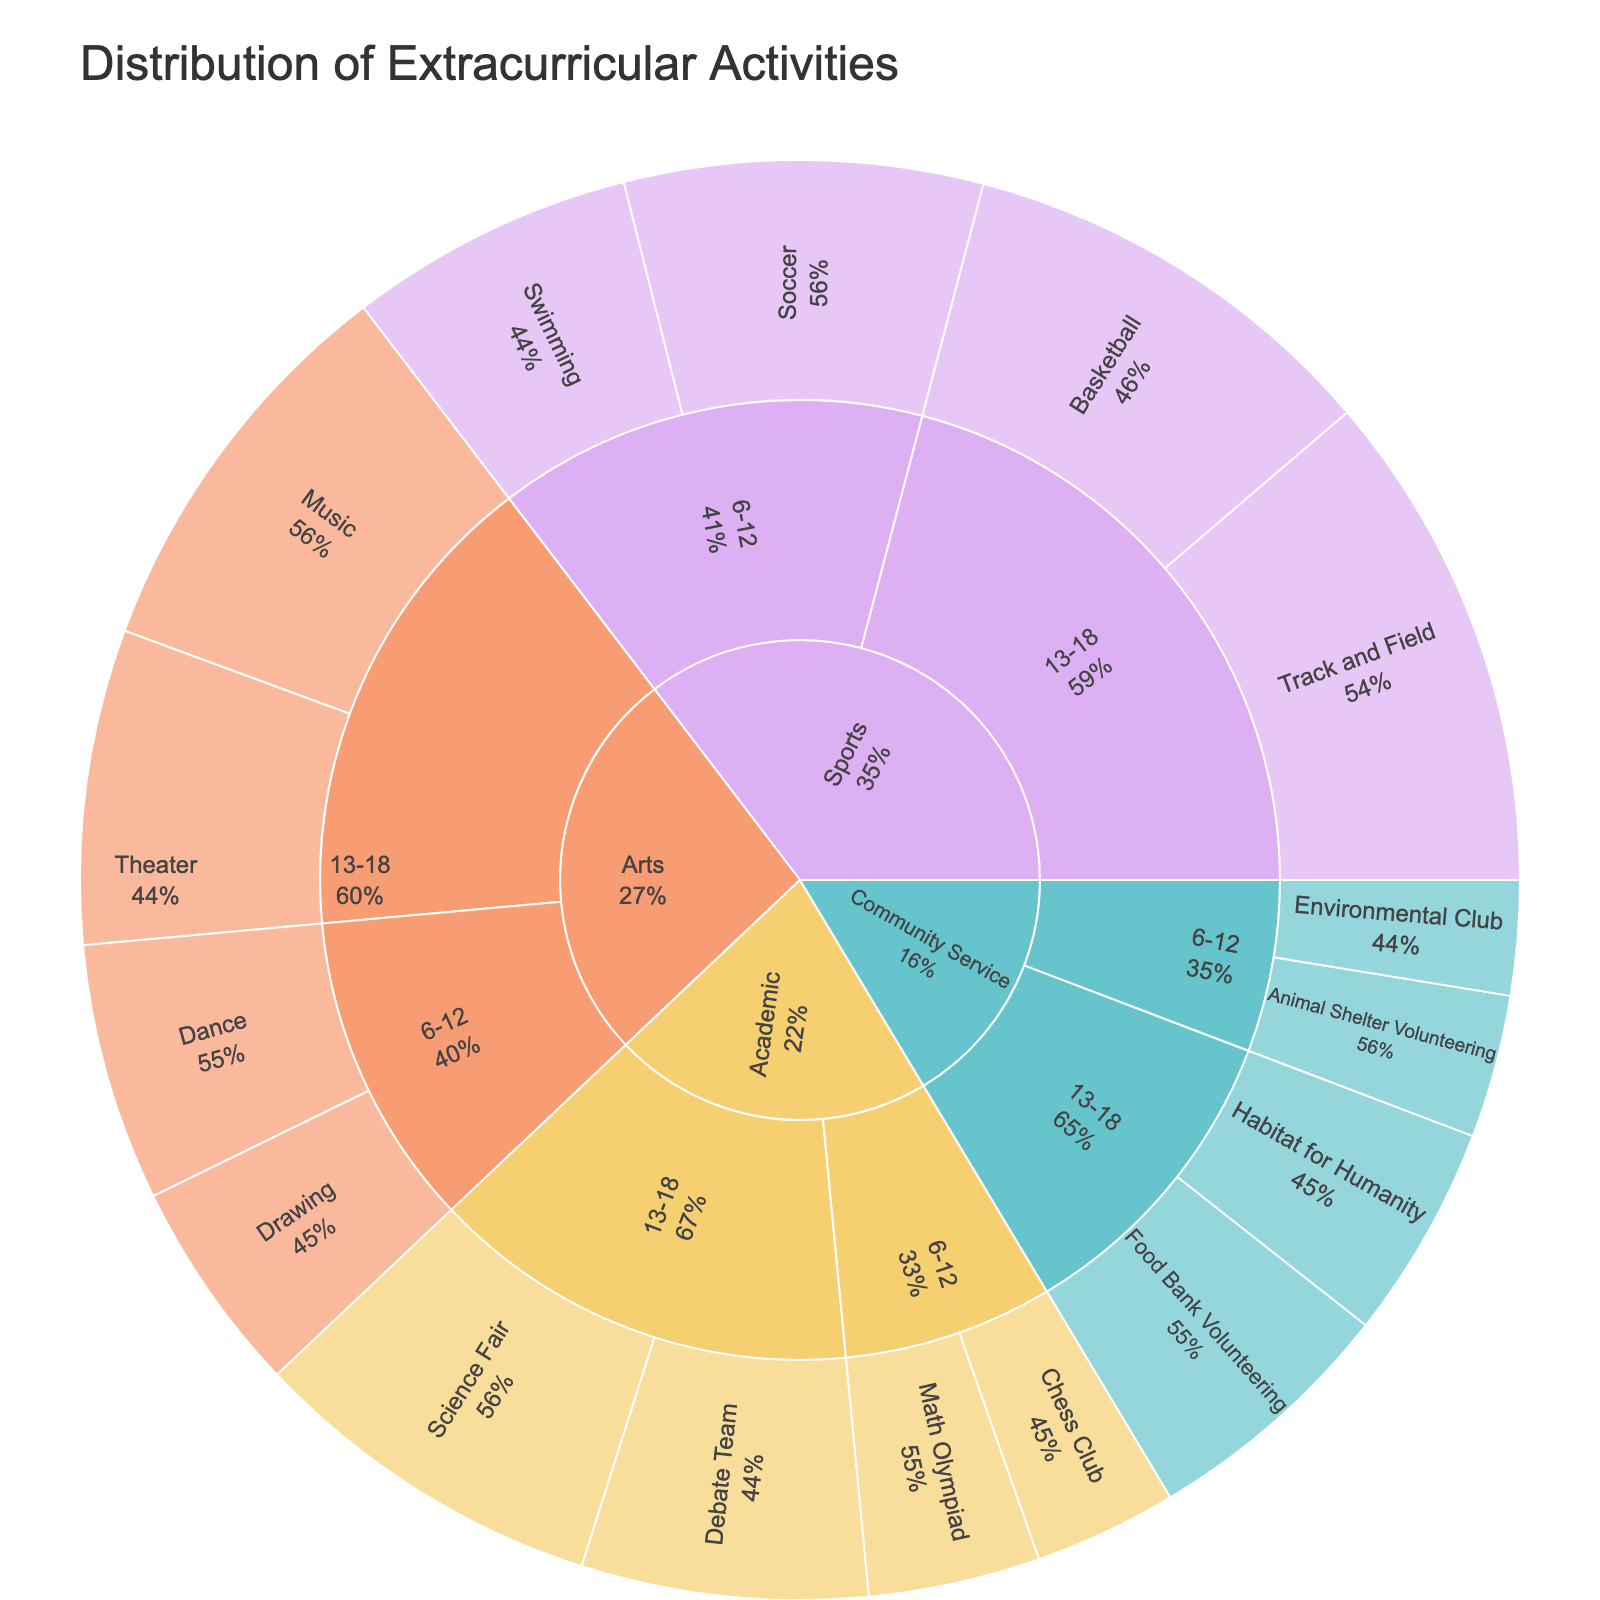What's the most popular extracurricular activity for students aged 13-18? By looking at the sunburst plot, locate the age group 13-18, then identify which activity has the largest segment within this group.
Answer: Track and Field Which category has the least participation among 6-12 year-olds? Find the segments for the 6-12 year group, then compare the sizes of the categories (Sports, Arts, Academic, Community Service). The smallest segment represents the category with the least participation.
Answer: Community Service How does the participation in Arts for 6-12 year-olds compare to Academic activities for the same age group? Locate the segments for 6-12 year-olds under Arts and Academic. Compare the total participation numbers of the activities within these categories.
Answer: Arts has higher participation What percentage of students participate in Community Service activities for both age groups combined? First find the total participation for Community Service activities (sum of all Community Service activities). Then, divide this value by the overall total participation and multiply by 100 to get the percentage.
Answer: 9.9% Which activity has more participants: Soccer (6-12) or Debate Team (13-18)? Locate Soccer under Sports for 6-12 and Debate Team under Academic for 13-18, then compare the size of their segments.
Answer: Debate Team In which age group is participation in Music higher? Locate Music under Arts for both age groups 6-12 and 13-18, then compare the sizes of their segments to see which age group has higher participation.
Answer: 13-18 What's the participation difference between Basketball (13-18) and Chess Club (6-12)? Find the participation numbers for Basketball (13-18) and Chess Club (6-12) on the plot. Then, subtract the participation in Chess Club from participation in Basketball.
Answer: 20 What is the total participation in Sports activities for both age groups? Sum up the participation numbers of all Sports activities for both age groups (6-12 and 13-18).
Answer: 110 How does participation in Drawing (6-12) compare to Habitat for Humanity (13-18)? Compare the sizes of the segments for Drawing under Arts (6-12) and Habitat for Humanity under Community Service (13-18).
Answer: Drawing has more participation Which age group has more diverse types of activities in Community Service? Check the number of unique activities listed under Community Service for both age groups 6-12 and 13-18.
Answer: Equal diversity 